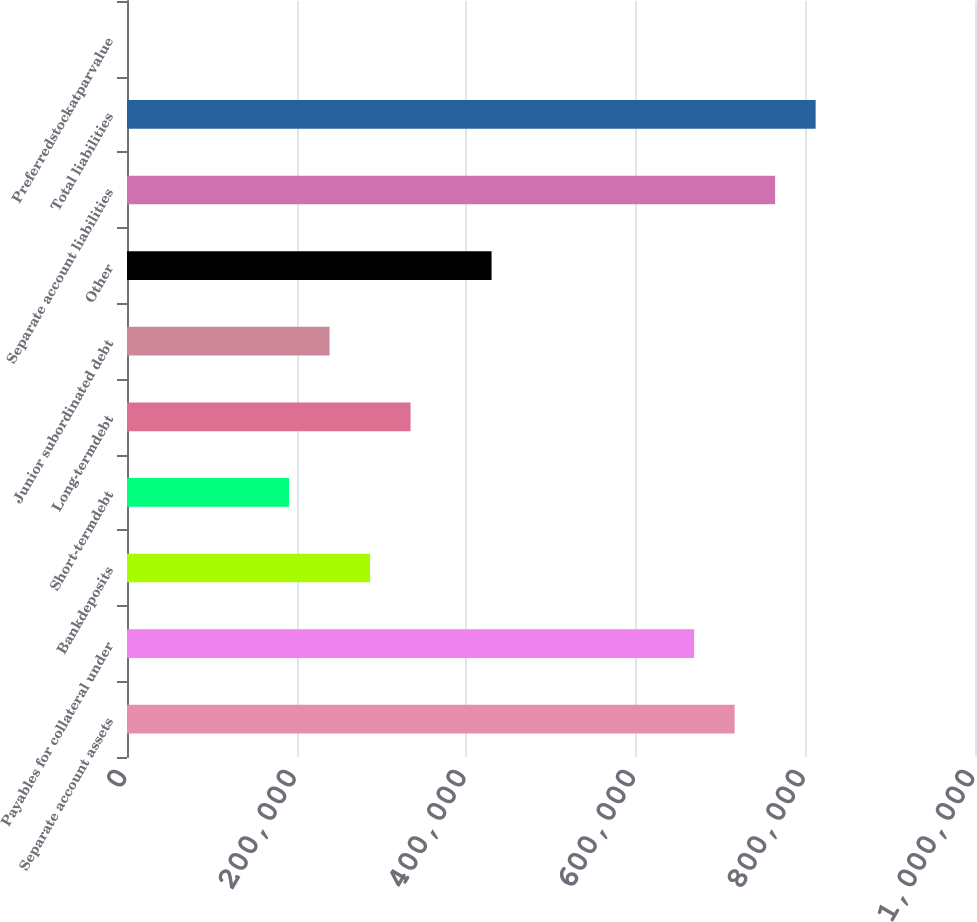Convert chart to OTSL. <chart><loc_0><loc_0><loc_500><loc_500><bar_chart><fcel>Separate account assets<fcel>Payables for collateral under<fcel>Bankdeposits<fcel>Short-termdebt<fcel>Long-termdebt<fcel>Junior subordinated debt<fcel>Other<fcel>Separate account liabilities<fcel>Total liabilities<fcel>Preferredstockatparvalue<nl><fcel>716539<fcel>668770<fcel>286616<fcel>191078<fcel>334385<fcel>238847<fcel>429924<fcel>764308<fcel>812077<fcel>1<nl></chart> 